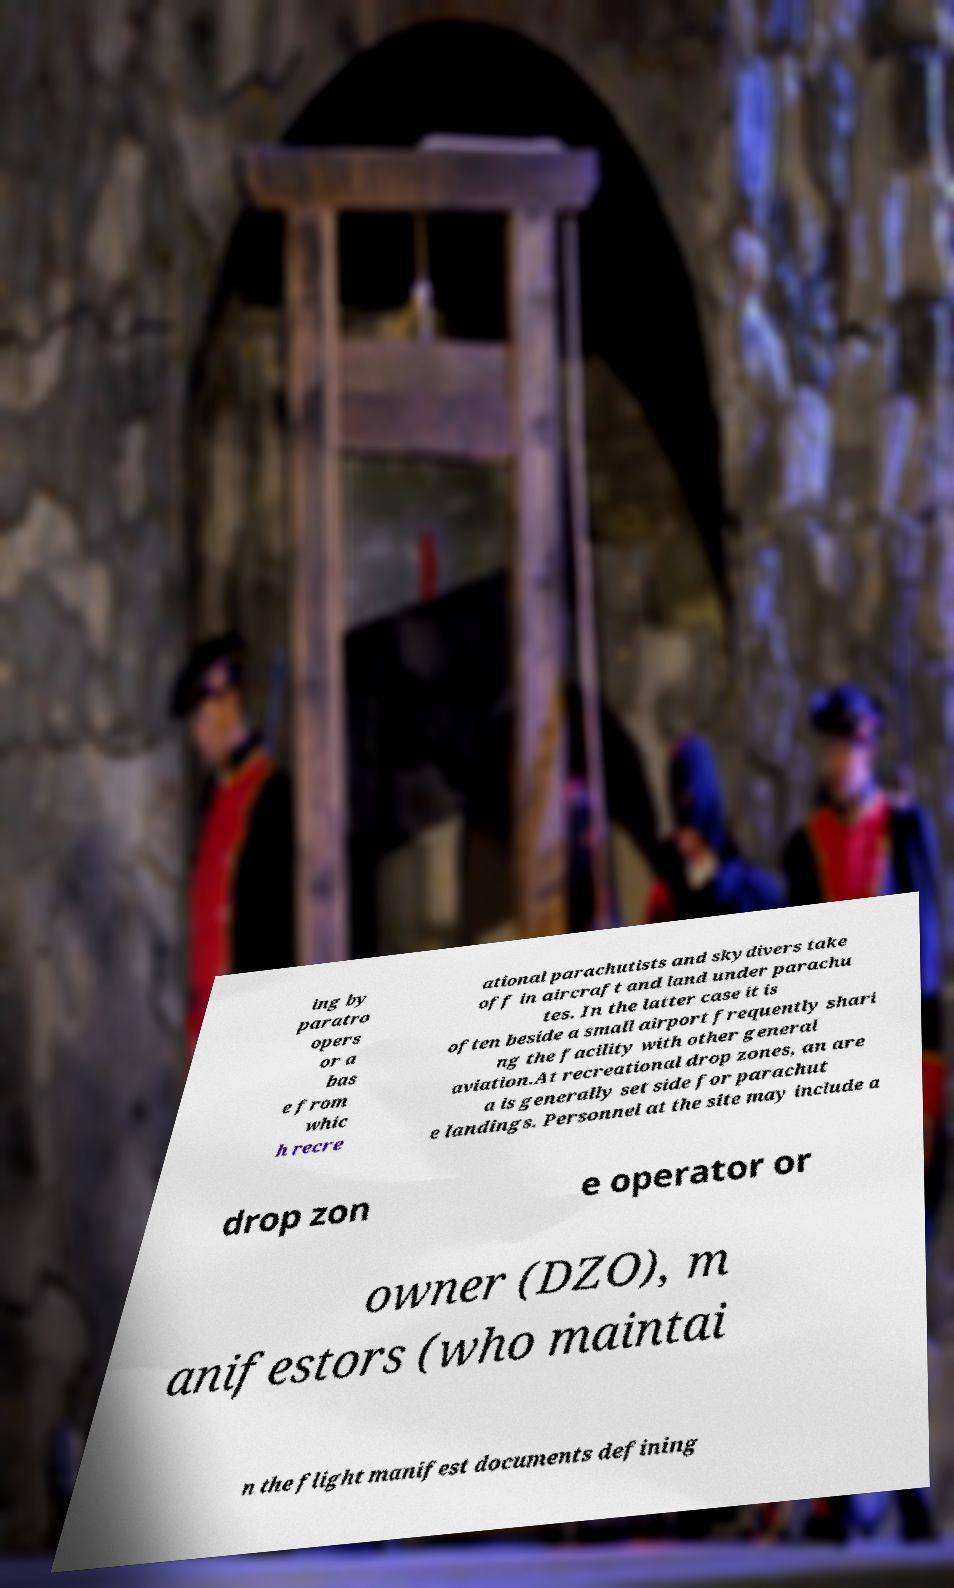Could you assist in decoding the text presented in this image and type it out clearly? ing by paratro opers or a bas e from whic h recre ational parachutists and skydivers take off in aircraft and land under parachu tes. In the latter case it is often beside a small airport frequently shari ng the facility with other general aviation.At recreational drop zones, an are a is generally set side for parachut e landings. Personnel at the site may include a drop zon e operator or owner (DZO), m anifestors (who maintai n the flight manifest documents defining 